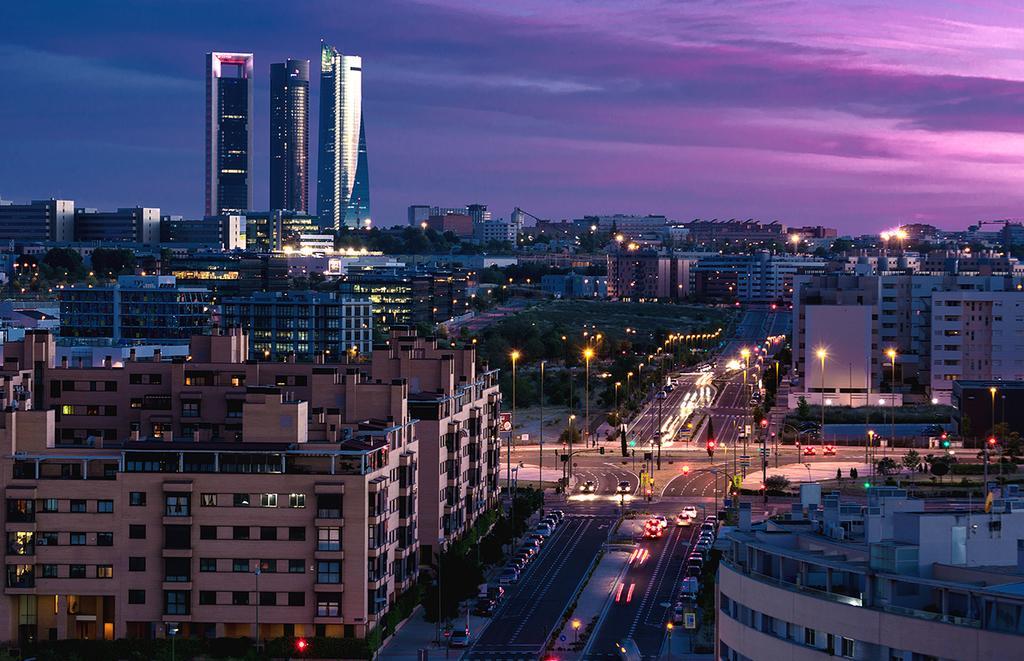Could you give a brief overview of what you see in this image? In the center of the image there is a road and we can see cars on the road. There are poles and we can see buildings. At the top there is sky. 